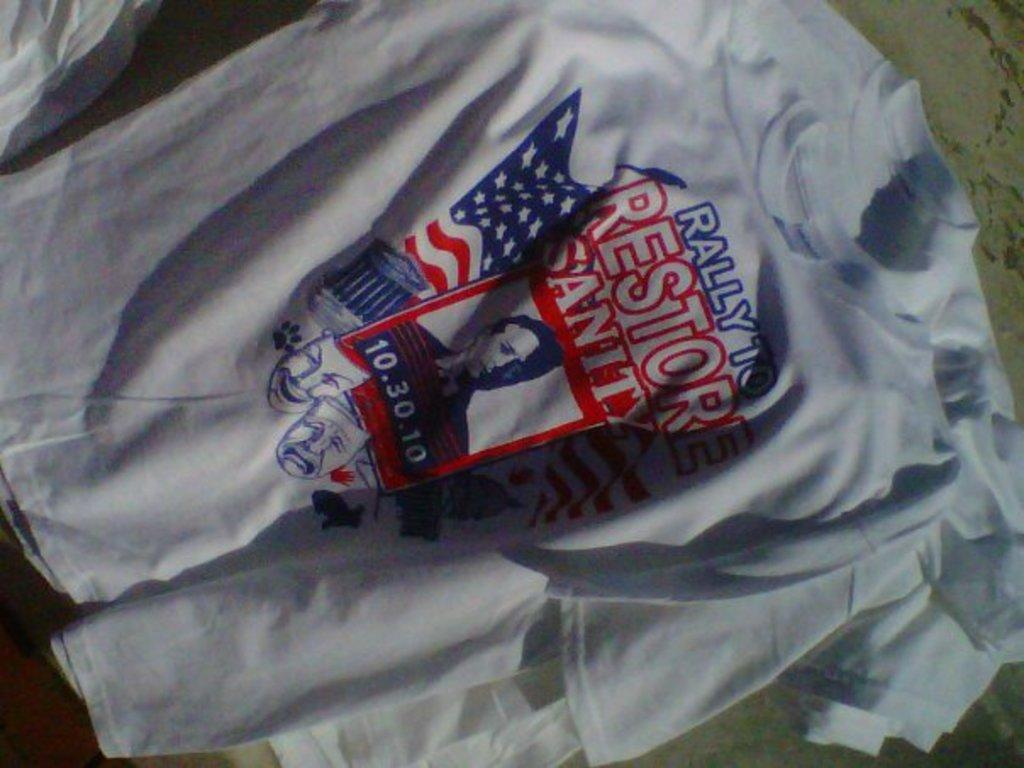What type of clothing is featured in the image? There are white t-shirts in the image. What is written on the t-shirts? There is writing on the t-shirts. What scientific property can be observed in the image? There is no scientific property mentioned or observable in the image, as it only features white t-shirts with writing on them. 